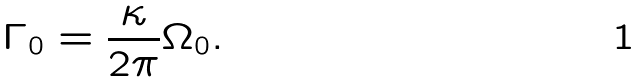<formula> <loc_0><loc_0><loc_500><loc_500>\Gamma _ { 0 } = \frac { \kappa } { 2 \pi } \Omega _ { 0 } .</formula> 